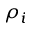<formula> <loc_0><loc_0><loc_500><loc_500>\rho _ { i }</formula> 